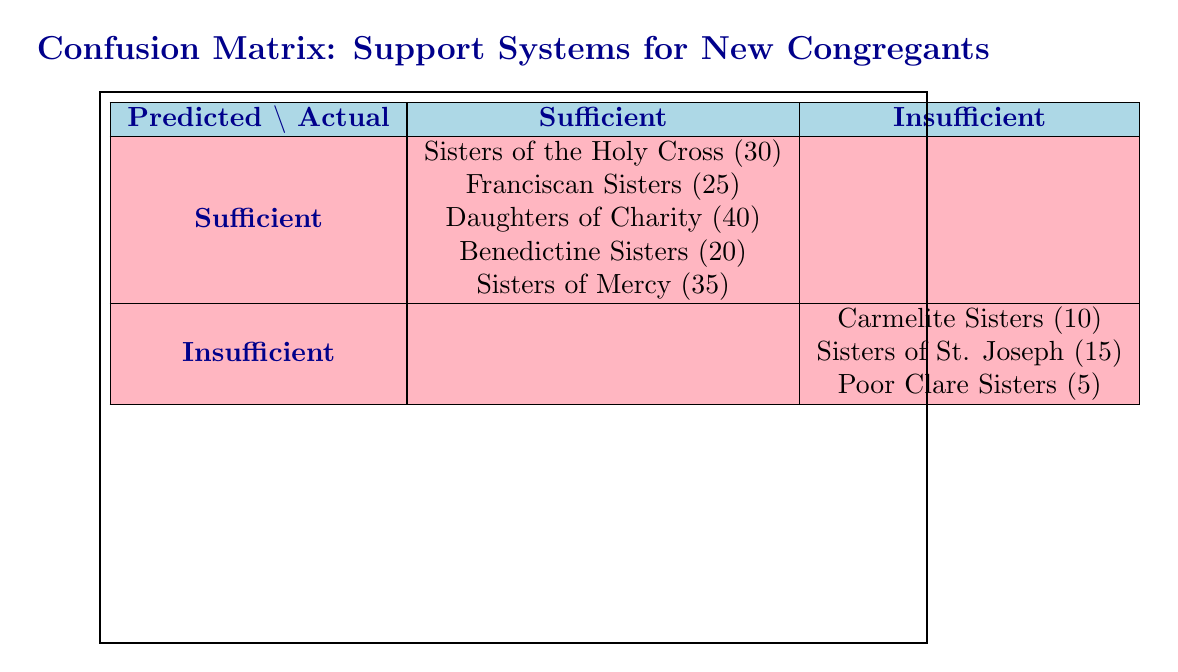What is the total number of new congregants in congregations with sufficient support? The table lists the number of new congregants for each congregation with sufficient support: Sisters of the Holy Cross (30), Franciscan Sisters (25), Daughters of Charity (40), Benedictine Sisters (20), and Sisters of Mercy (35). Adding these numbers gives: 30 + 25 + 40 + 20 + 35 = 150.
Answer: 150 How many congregations have an insufficient support status? The table shows three congregations with insufficient support: Carmelite Sisters (10), Sisters of St. Joseph (15), and Poor Clare Sisters (5). Thus, there are three congregations listed under this category.
Answer: 3 Which congregation has the lowest number of new congregants? Among the congregations listed under insufficient support, the Poor Clare Sisters have the lowest number of new congregants at 5, which is lower than Carmelite Sisters (10) and Sisters of St. Joseph (15).
Answer: Poor Clare Sisters Is it true that all congregations with sufficient support have a high feeling of belonging? Based on the table, all four congregations with sufficient support (Sisters of the Holy Cross, Franciscan Sisters, Daughters of Charity, Benedictine Sisters, Sisters of Mercy) also have a feeling of belonging categorized as high. Thus, the statement is true.
Answer: Yes What is the average number of new congregants in congregations with insufficient support? The new congregants with insufficient support are: Carmelite Sisters (10), Sisters of St. Joseph (15), and Poor Clare Sisters (5). The total is 10 + 15 + 5 = 30. There are 3 congregations, so the average is 30/3 = 10.
Answer: 10 Which type of support system correlates with a high feeling of belonging? Looking closely at the feelings of belonging among the congregations: all congregations with sufficient support have 'High' feelings of belonging, while all congregations with insufficient support have 'Low'. This indicates that sufficient support correlates with a high feeling of belonging.
Answer: Sufficient support How many congregants reported a low feeling of belonging? The table shows the number of new congregants with a low feeling of belonging: Carmelite Sisters (10), Sisters of St. Joseph (15), and Poor Clare Sisters (5). Adding these gives 10 + 15 + 5 = 30 new congregants experiencing a low feeling of belonging.
Answer: 30 What is the difference in the number of new congregants between the congregation with the most and the least support? The congregation with the highest number of new congregants is Daughters of Charity with 40, and the one with the least is Poor Clare Sisters with 5. The difference is 40 - 5 = 35.
Answer: 35 